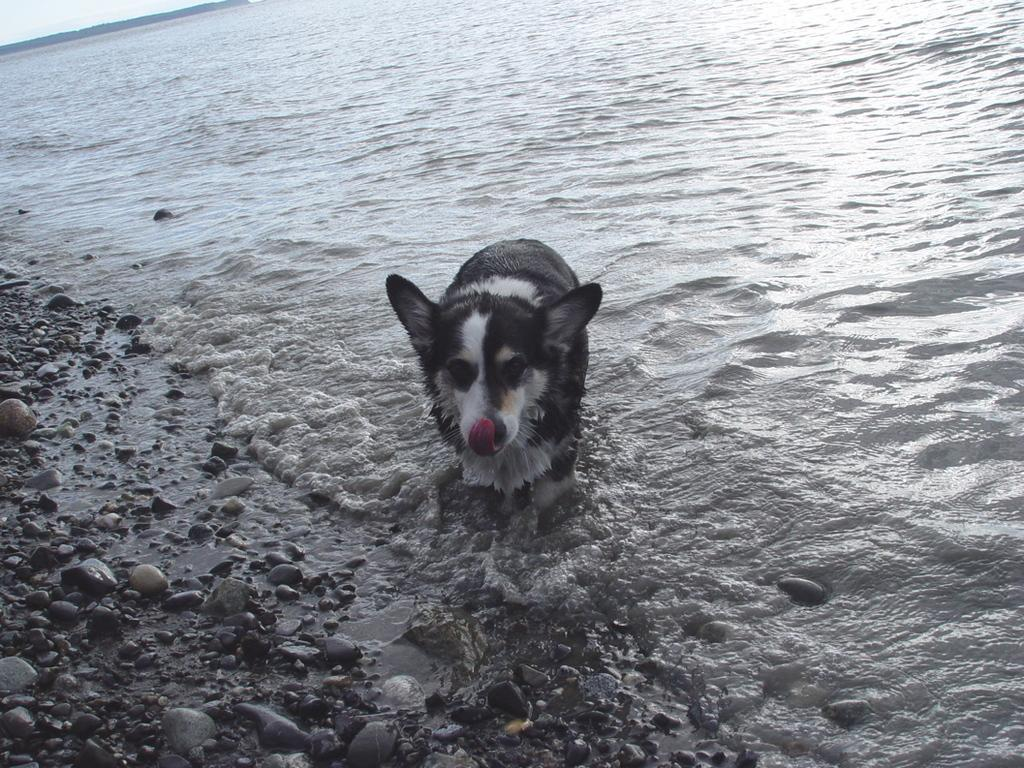What animal can be seen in the image? There is a dog in the image. Where is the dog located in the image? The dog is standing in the water. What can be seen on the left side of the image? There are stones on the left side of the image. What type of government is depicted in the image? There is no depiction of a government in the image; it features a dog standing in the water with stones on the left side. 